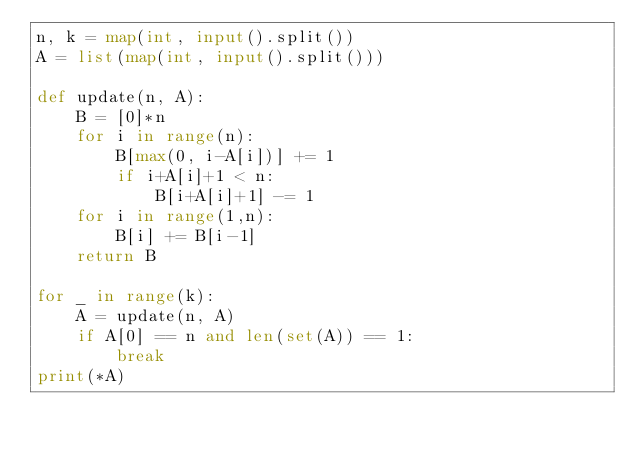<code> <loc_0><loc_0><loc_500><loc_500><_Python_>n, k = map(int, input().split())
A = list(map(int, input().split()))

def update(n, A):
    B = [0]*n
    for i in range(n):
        B[max(0, i-A[i])] += 1
        if i+A[i]+1 < n:
            B[i+A[i]+1] -= 1
    for i in range(1,n):
        B[i] += B[i-1]
    return B

for _ in range(k):
    A = update(n, A)
    if A[0] == n and len(set(A)) == 1:
        break
print(*A)</code> 